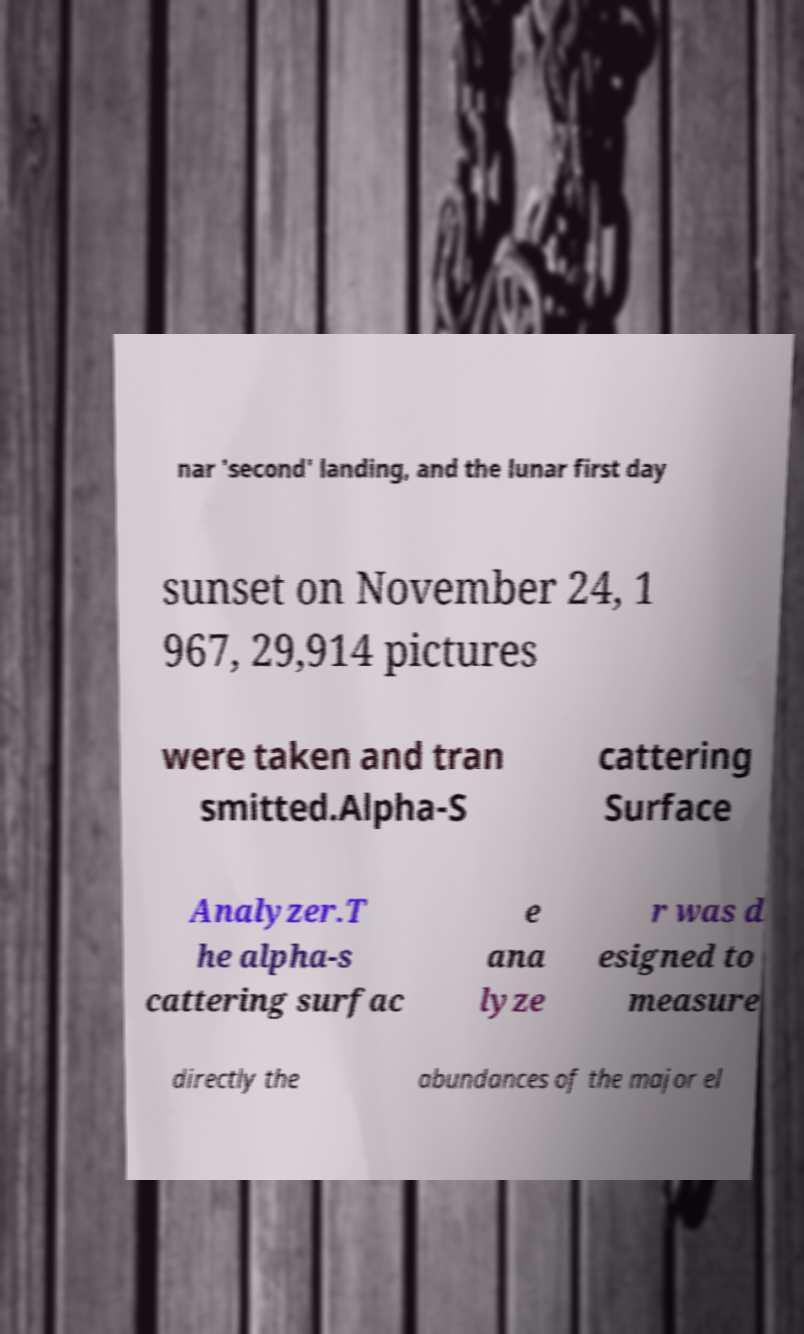For documentation purposes, I need the text within this image transcribed. Could you provide that? nar 'second' landing, and the lunar first day sunset on November 24, 1 967, 29,914 pictures were taken and tran smitted.Alpha-S cattering Surface Analyzer.T he alpha-s cattering surfac e ana lyze r was d esigned to measure directly the abundances of the major el 